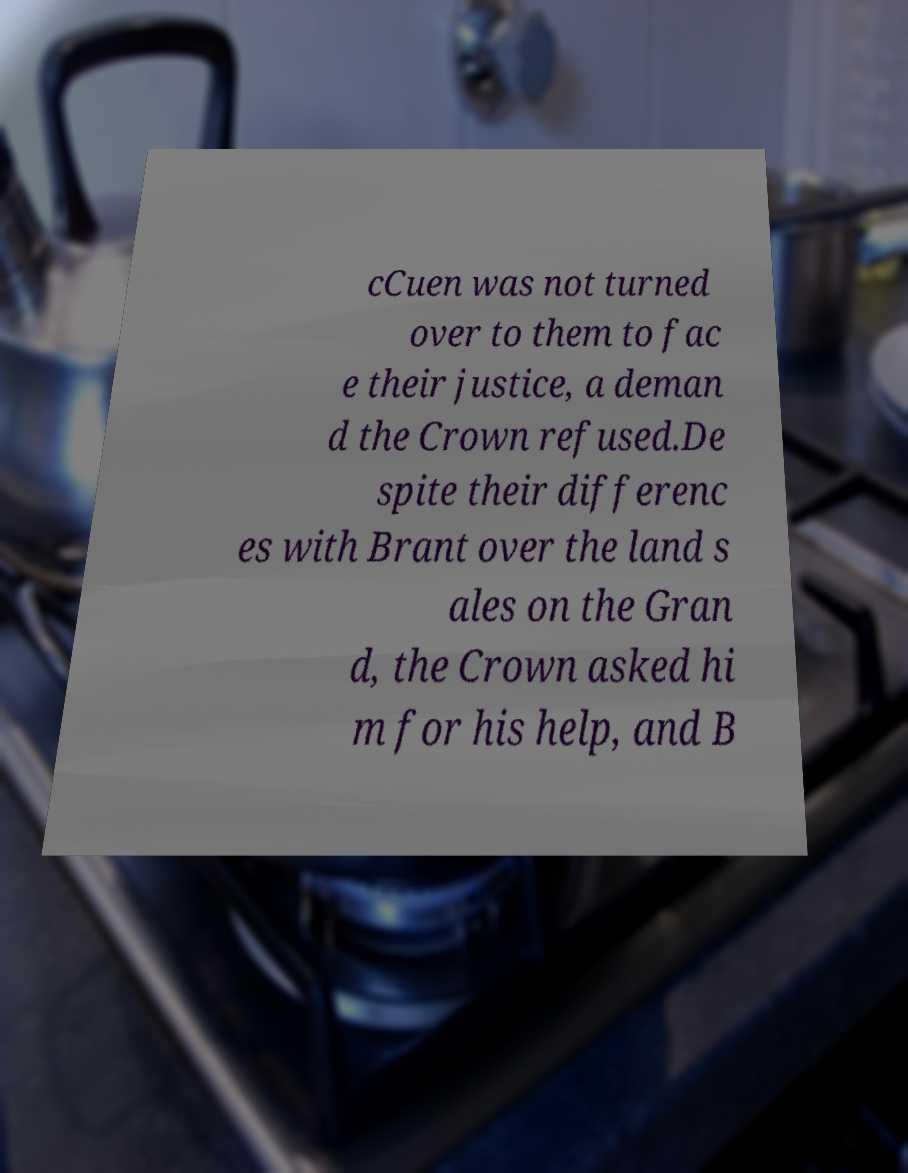For documentation purposes, I need the text within this image transcribed. Could you provide that? cCuen was not turned over to them to fac e their justice, a deman d the Crown refused.De spite their differenc es with Brant over the land s ales on the Gran d, the Crown asked hi m for his help, and B 